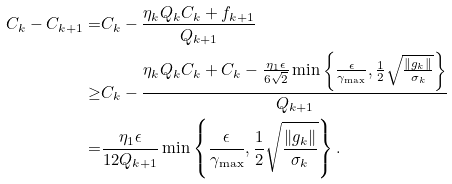Convert formula to latex. <formula><loc_0><loc_0><loc_500><loc_500>C _ { k } - C _ { k + 1 } = & C _ { k } - \frac { \eta _ { k } Q _ { k } C _ { k } + f _ { k + 1 } } { Q _ { k + 1 } } \\ \geq & C _ { k } - \frac { \eta _ { k } Q _ { k } C _ { k } + C _ { k } - \frac { \eta _ { 1 } \epsilon } { 6 \sqrt { 2 } } \min \left \{ \frac { \epsilon } { \gamma _ { \max } } , \frac { 1 } { 2 } \sqrt { \frac { \| g _ { k } \| } { \sigma _ { k } } } \right \} } { Q _ { k + 1 } } \\ = & \frac { \eta _ { 1 } \epsilon } { 1 2 Q _ { k + 1 } } \min \left \{ \frac { \epsilon } { \gamma _ { \max } } , \frac { 1 } { 2 } \sqrt { \frac { \| g _ { k } \| } { \sigma _ { k } } } \right \} .</formula> 